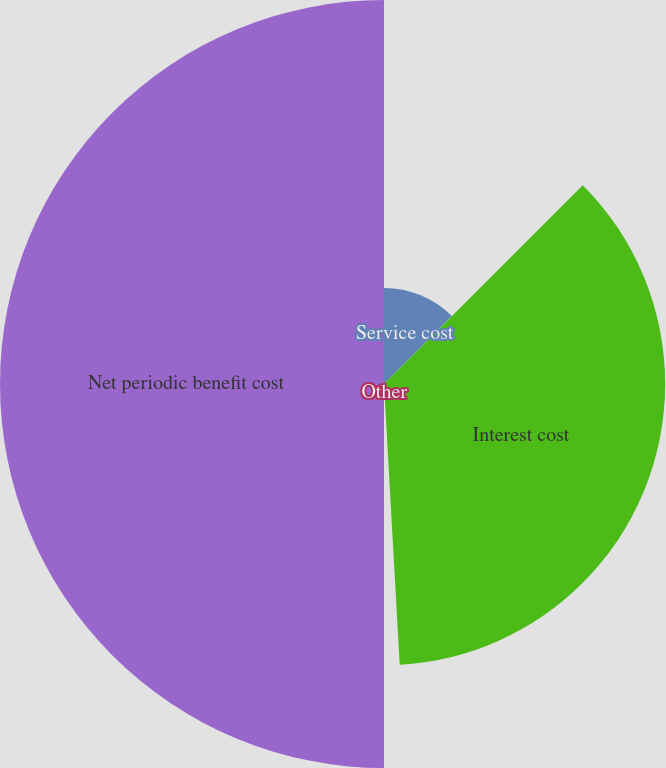<chart> <loc_0><loc_0><loc_500><loc_500><pie_chart><fcel>Service cost<fcel>Interest cost<fcel>Other<fcel>Net periodic benefit cost<nl><fcel>12.5%<fcel>36.61%<fcel>0.89%<fcel>50.0%<nl></chart> 